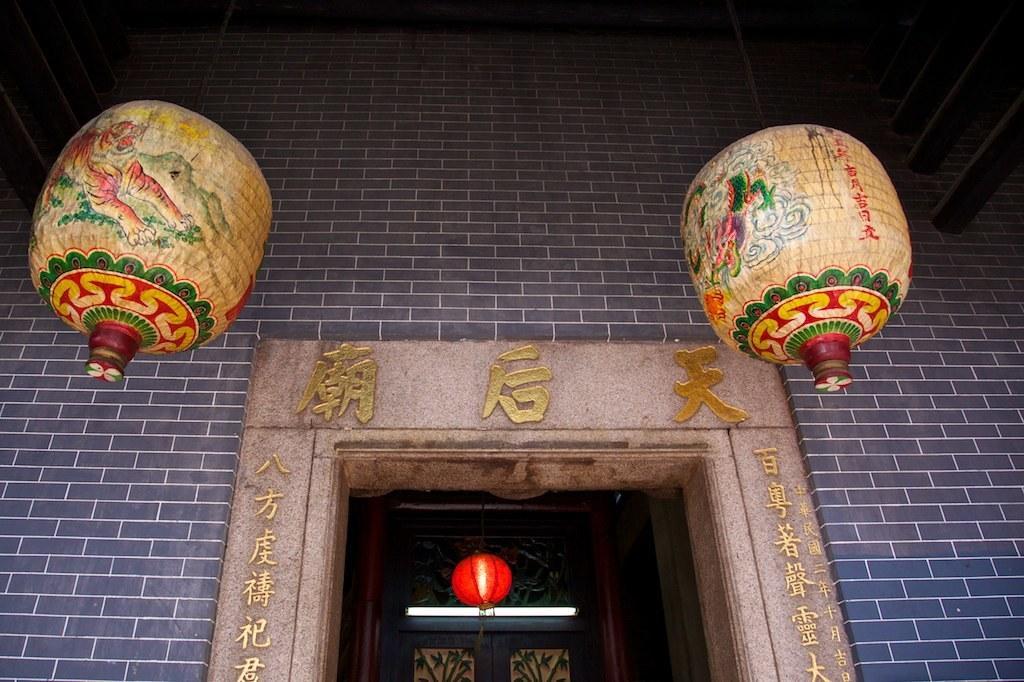In one or two sentences, can you explain what this image depicts? In this image I can see the building which is made up bricks which is violet in color and the entrance arch which is cream in color. I can see two lamps which are green, red and cream in color and a lamp which is orange in color. 